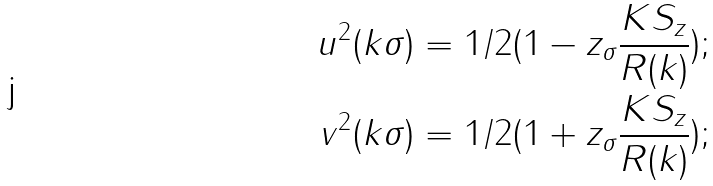<formula> <loc_0><loc_0><loc_500><loc_500>u ^ { 2 } ( k \sigma ) = 1 / 2 ( 1 - z _ { \sigma } \frac { K S _ { z } } { R ( k ) } ) ; \\ v ^ { 2 } ( k \sigma ) = 1 / 2 ( 1 + z _ { \sigma } \frac { K S _ { z } } { R ( k ) } ) ;</formula> 